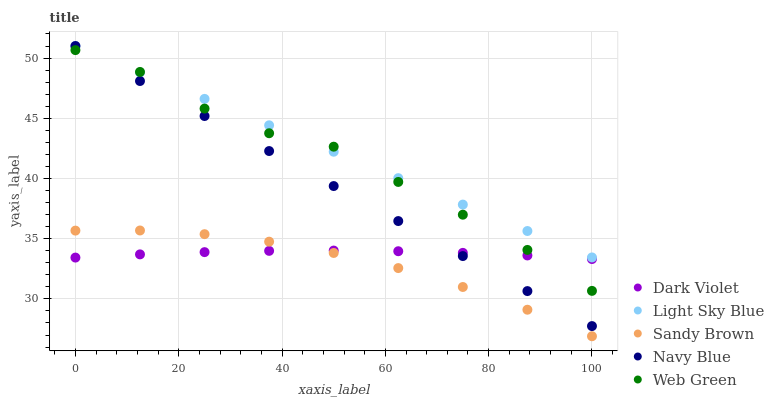Does Sandy Brown have the minimum area under the curve?
Answer yes or no. Yes. Does Light Sky Blue have the maximum area under the curve?
Answer yes or no. Yes. Does Light Sky Blue have the minimum area under the curve?
Answer yes or no. No. Does Sandy Brown have the maximum area under the curve?
Answer yes or no. No. Is Navy Blue the smoothest?
Answer yes or no. Yes. Is Web Green the roughest?
Answer yes or no. Yes. Is Light Sky Blue the smoothest?
Answer yes or no. No. Is Light Sky Blue the roughest?
Answer yes or no. No. Does Sandy Brown have the lowest value?
Answer yes or no. Yes. Does Light Sky Blue have the lowest value?
Answer yes or no. No. Does Light Sky Blue have the highest value?
Answer yes or no. Yes. Does Sandy Brown have the highest value?
Answer yes or no. No. Is Dark Violet less than Light Sky Blue?
Answer yes or no. Yes. Is Navy Blue greater than Sandy Brown?
Answer yes or no. Yes. Does Web Green intersect Light Sky Blue?
Answer yes or no. Yes. Is Web Green less than Light Sky Blue?
Answer yes or no. No. Is Web Green greater than Light Sky Blue?
Answer yes or no. No. Does Dark Violet intersect Light Sky Blue?
Answer yes or no. No. 